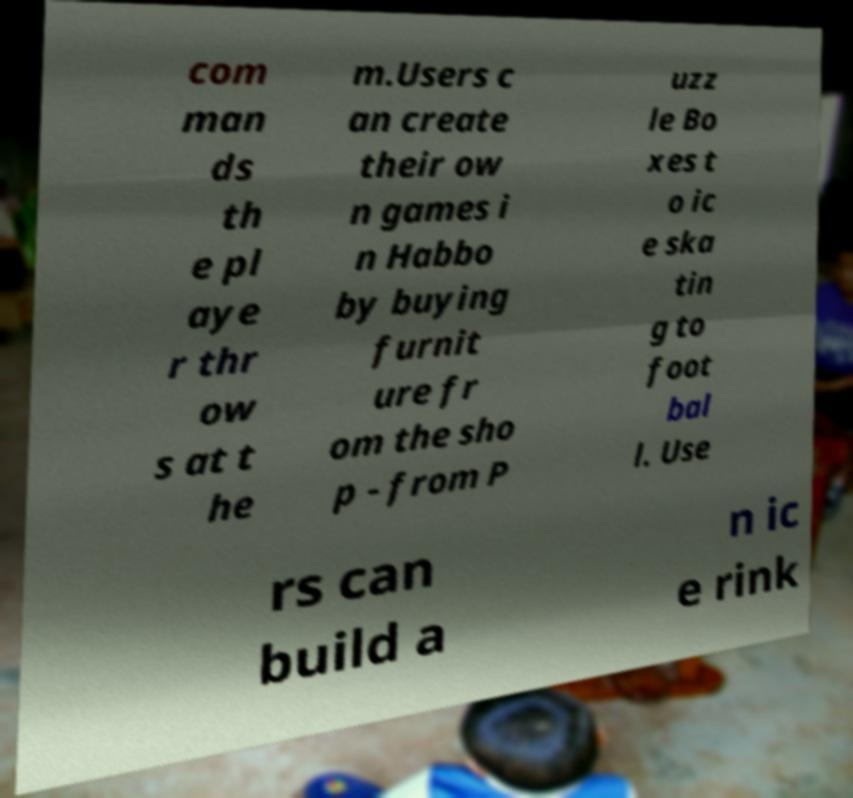Can you accurately transcribe the text from the provided image for me? com man ds th e pl aye r thr ow s at t he m.Users c an create their ow n games i n Habbo by buying furnit ure fr om the sho p - from P uzz le Bo xes t o ic e ska tin g to foot bal l. Use rs can build a n ic e rink 